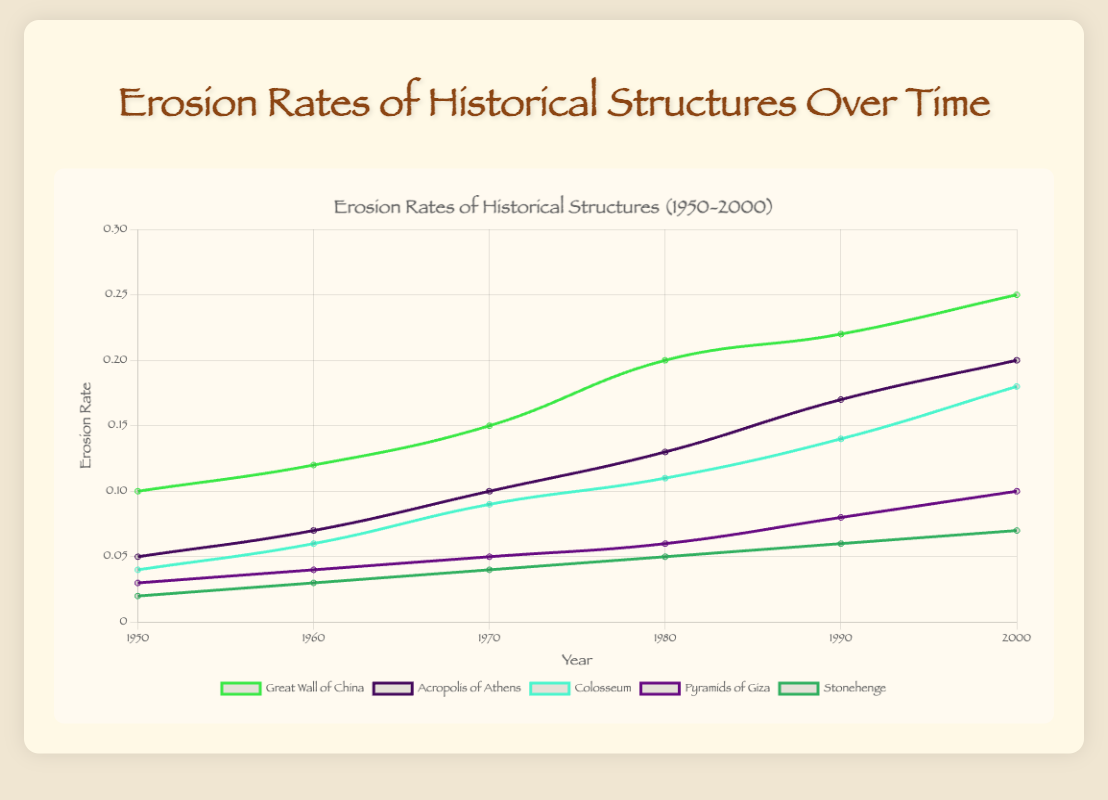What's the overall trend of erosion rates for the Great Wall of China from 1950 to 2000? Observing the line for the Great Wall of China, the erosion rate starts at 0.1 in 1950 and consistently increases up to 0.25 in 2000. This indicates a growing trend in erosion rates over the 50-year period.
Answer: Increasing Which historical structure experienced the highest erosion rate in the year 2000? Looking at the end points of all the lines in the year 2000, the Great Wall of China exhibits the highest erosion rate at 0.25.
Answer: Great Wall of China By how much did the erosion rate of the Acropolis of Athens increase from 1950 to 2000? The erosion rate for the Acropolis of Athens increased from 0.05 in 1950 to 0.2 in 2000. The calculation is 0.2 - 0.05 = 0.15.
Answer: 0.15 Compare the erosion rate of the Pyramids of Giza in 1960 and 2000. Which year had the higher rate and by how much? In 1960, the erosion rate for the Pyramids of Giza was 0.04 and in 2000, it was 0.1. The difference is 0.1 - 0.04 = 0.06, with 2000 having the higher rate.
Answer: 2000 by 0.06 What is the average erosion rate of Stonehenge over the years 1950, 1960, and 1970? The erosion rates for Stonehenge in the specified years are 0.02, 0.03, and 0.04. The average is calculated as (0.02 + 0.03 + 0.04) / 3 = 0.03.
Answer: 0.03 Which structure showed a consistent increase in erosion rate over each recorded decade? By observing the lines for each structure, both the Acropolis of Athens and the Great Wall of China show consistent increases in erosion rates over each decade from 1950 to 2000.
Answer: Acropolis of Athens, Great Wall of China How does the erosion rate of the Colosseum in 1980 compare to the erosion rate of Stonehenge in 1980? The erosion rate for the Colosseum in 1980 is 0.11 and for Stonehenge, it is 0.05. Therefore, the Colosseum had a higher erosion rate in 1980.
Answer: Colosseum had a higher erosion rate What is the combined erosion rate of the Colosseum and the Pyramids of Giza in the year 1970? The erosion rate of the Colosseum in 1970 is 0.09 and for the Pyramids of Giza, it is 0.05. The combined rate is 0.09 + 0.05 = 0.14.
Answer: 0.14 What trend can be observed for the erosion rate of Stonehenge from 1950 to 2000? The erosion rate for Stonehenge starts at 0.02 in 1950 and increases gradually to 0.07 in 2000. This indicates a steady upward trend over the 50 years.
Answer: Increasing Which structure had the smallest increase in erosion rate between 1950 and 2000? By comparing the increases, Stonehenge had the smallest increase, moving from 0.02 in 1950 to 0.07 in 2000, which is an increase of 0.05.
Answer: Stonehenge 